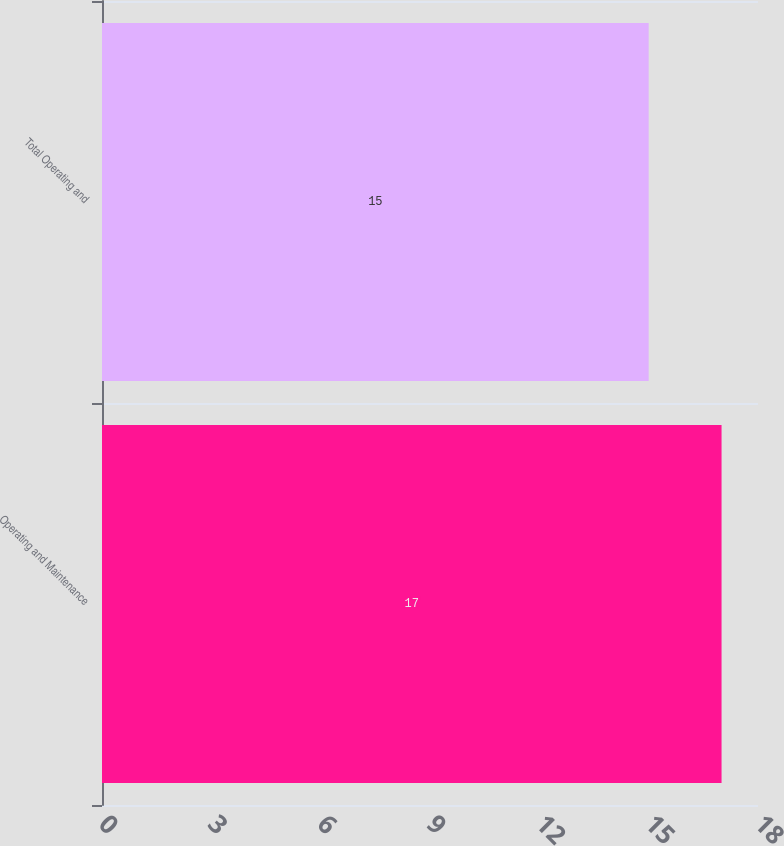Convert chart. <chart><loc_0><loc_0><loc_500><loc_500><bar_chart><fcel>Operating and Maintenance<fcel>Total Operating and<nl><fcel>17<fcel>15<nl></chart> 